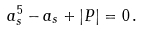<formula> <loc_0><loc_0><loc_500><loc_500>a _ { s } ^ { 5 } - a _ { s } + | P | = 0 \, .</formula> 